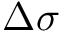<formula> <loc_0><loc_0><loc_500><loc_500>\Delta \sigma</formula> 